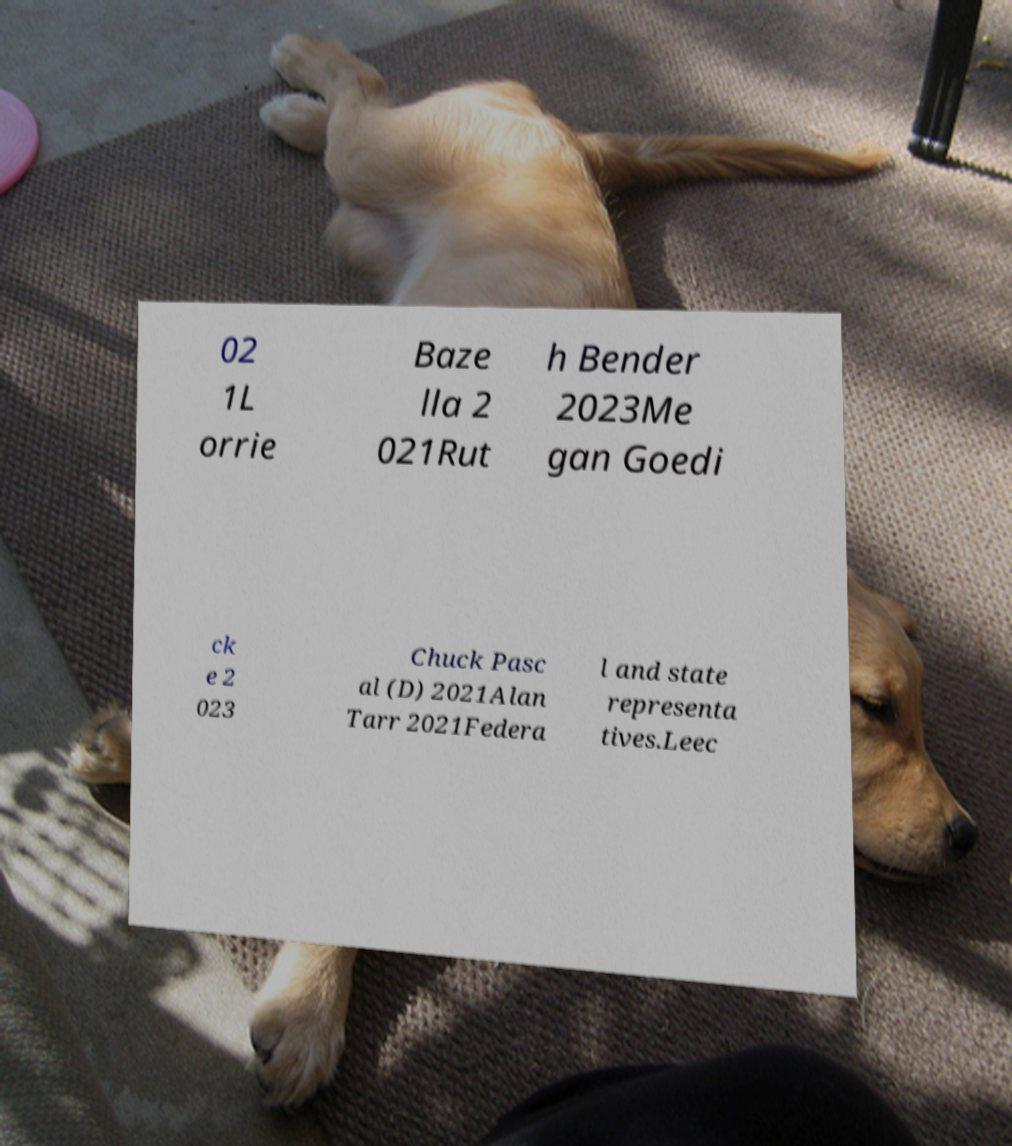Can you accurately transcribe the text from the provided image for me? 02 1L orrie Baze lla 2 021Rut h Bender 2023Me gan Goedi ck e 2 023 Chuck Pasc al (D) 2021Alan Tarr 2021Federa l and state representa tives.Leec 